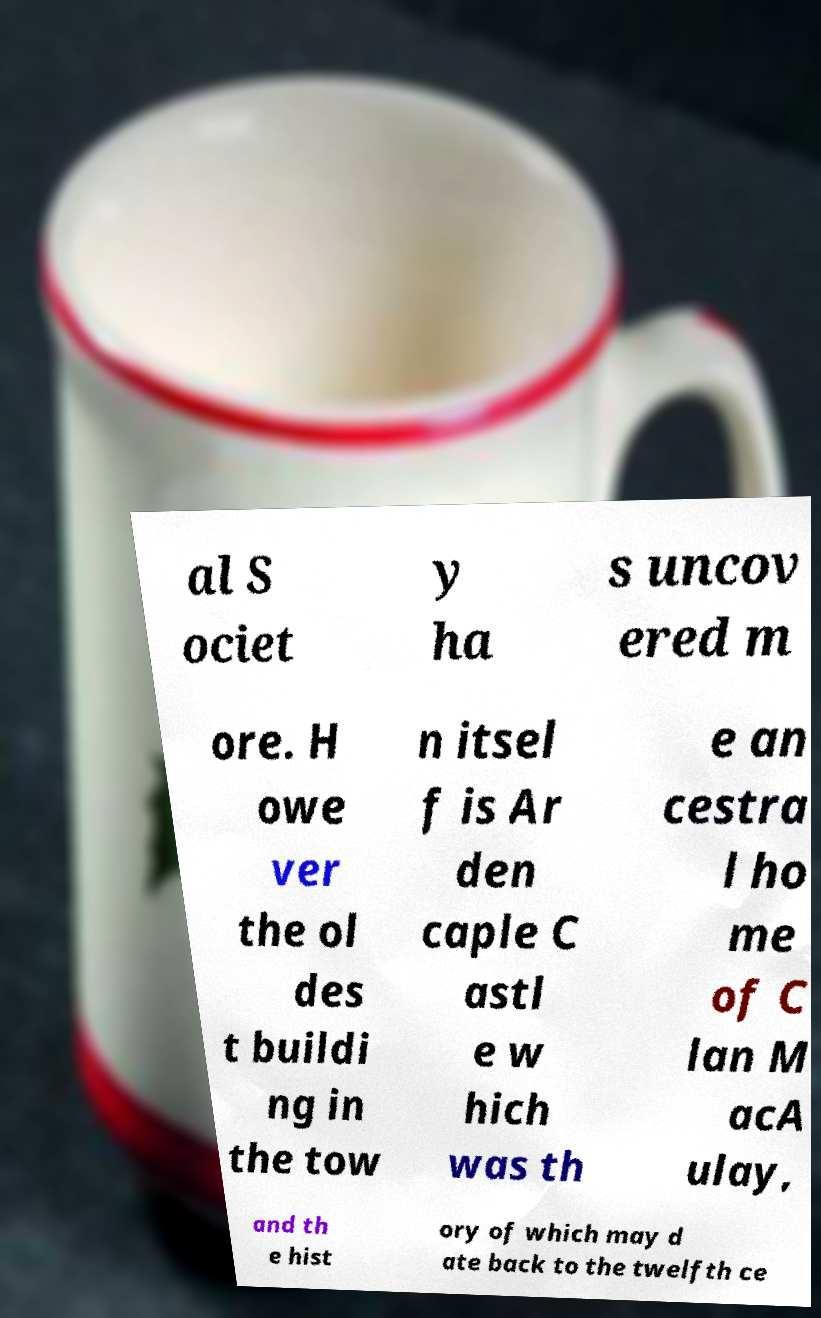Please read and relay the text visible in this image. What does it say? al S ociet y ha s uncov ered m ore. H owe ver the ol des t buildi ng in the tow n itsel f is Ar den caple C astl e w hich was th e an cestra l ho me of C lan M acA ulay, and th e hist ory of which may d ate back to the twelfth ce 